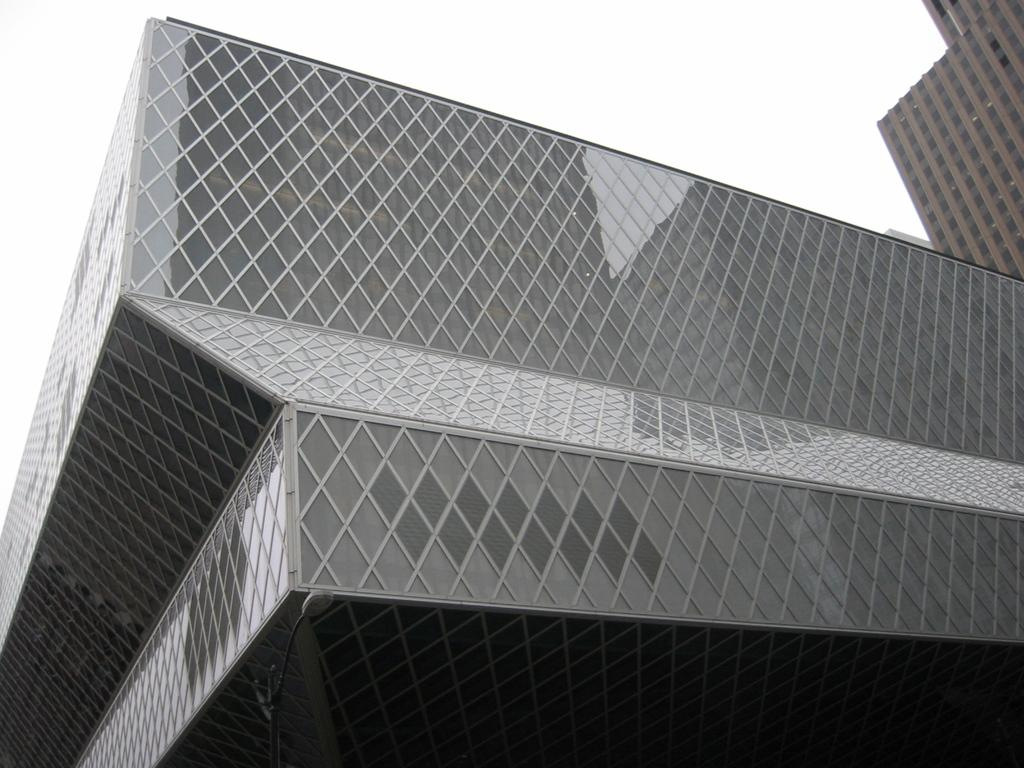What type of structures can be seen in the image? There are buildings in the image. What part of the natural environment is visible in the image? The sky is visible in the image. What is the color scheme of the image? The image is black and white in color. What type of advice can be seen written on the buildings in the image? There is no advice visible on the buildings in the image, as it is a black and white image of buildings and the sky. 